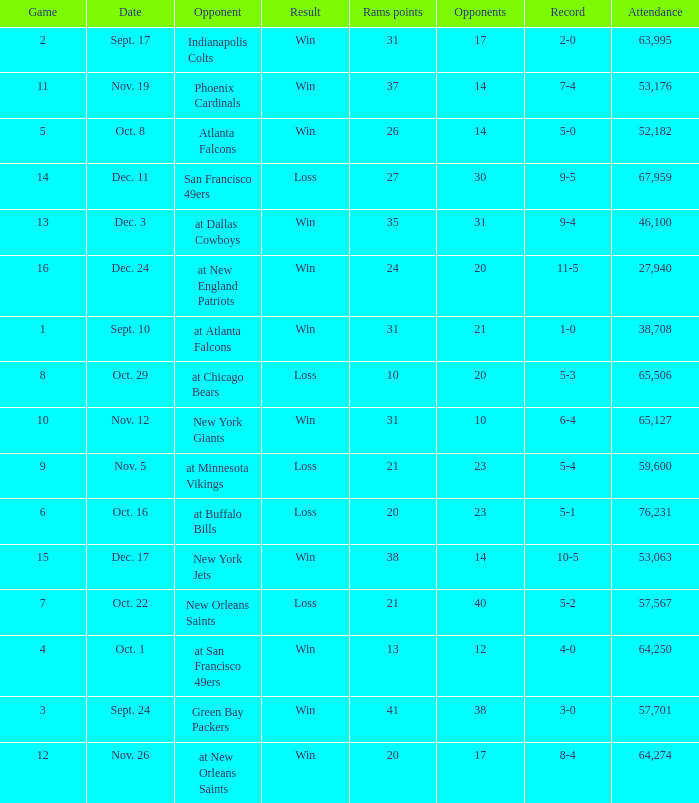What was the attendance where the record was 8-4? 64274.0. 